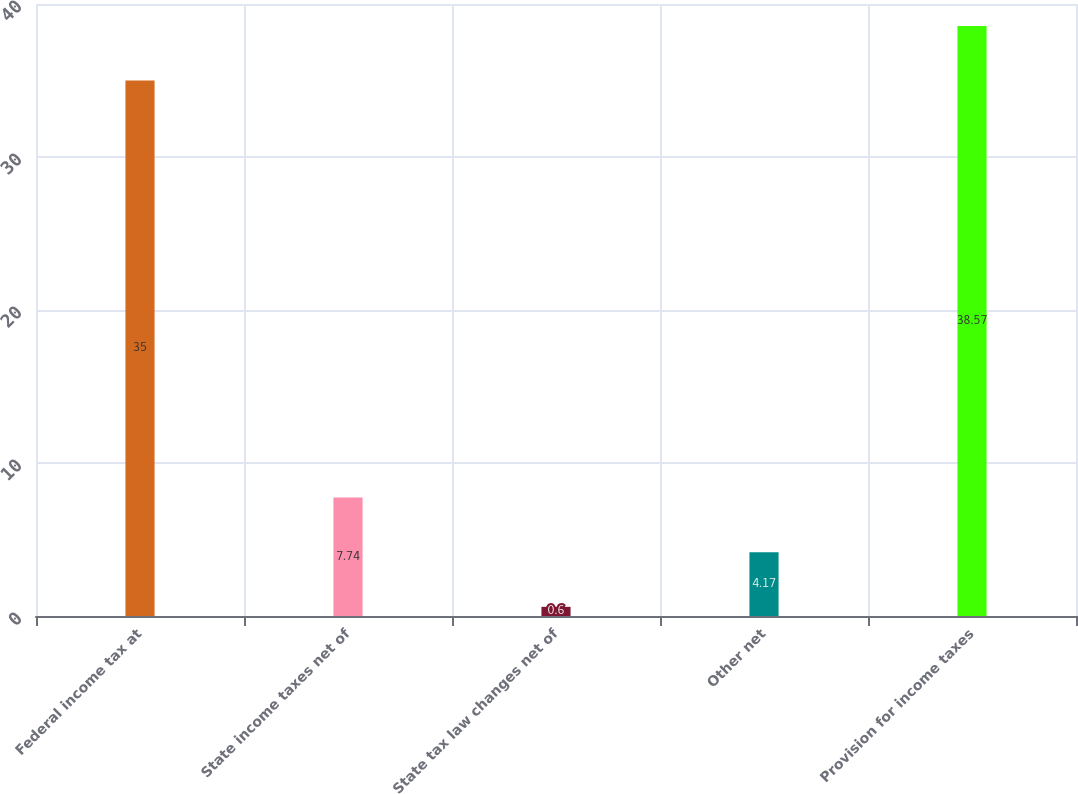Convert chart. <chart><loc_0><loc_0><loc_500><loc_500><bar_chart><fcel>Federal income tax at<fcel>State income taxes net of<fcel>State tax law changes net of<fcel>Other net<fcel>Provision for income taxes<nl><fcel>35<fcel>7.74<fcel>0.6<fcel>4.17<fcel>38.57<nl></chart> 